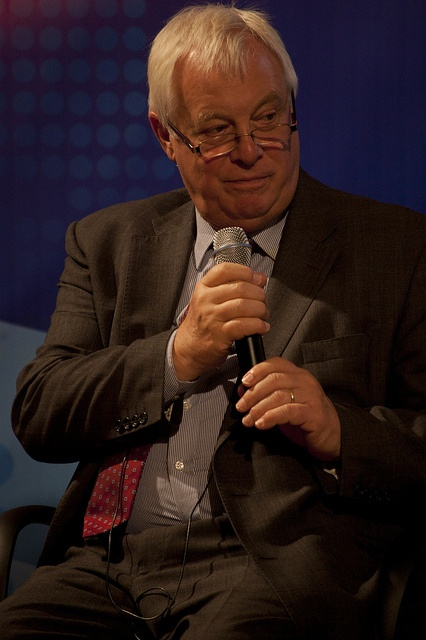Describe the objects in this image and their specific colors. I can see people in black, maroon, and brown tones, chair in maroon, black, and darkblue tones, and tie in maroon, black, and brown tones in this image. 